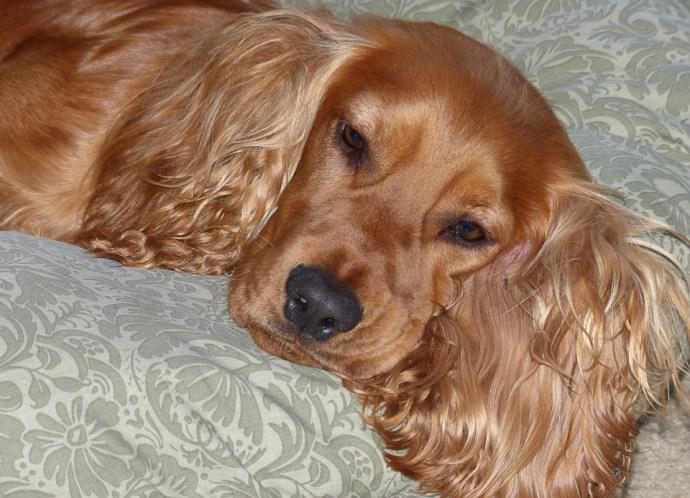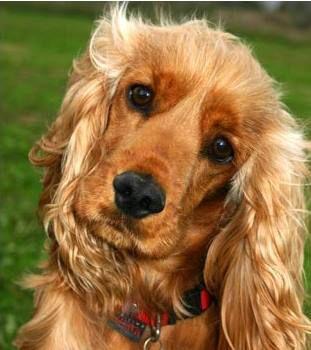The first image is the image on the left, the second image is the image on the right. Analyze the images presented: Is the assertion "An image shows one dog with its head resting on some type of grey soft surface." valid? Answer yes or no. Yes. The first image is the image on the left, the second image is the image on the right. For the images shown, is this caption "The dog in the image on the left is lying on a grey material." true? Answer yes or no. Yes. 